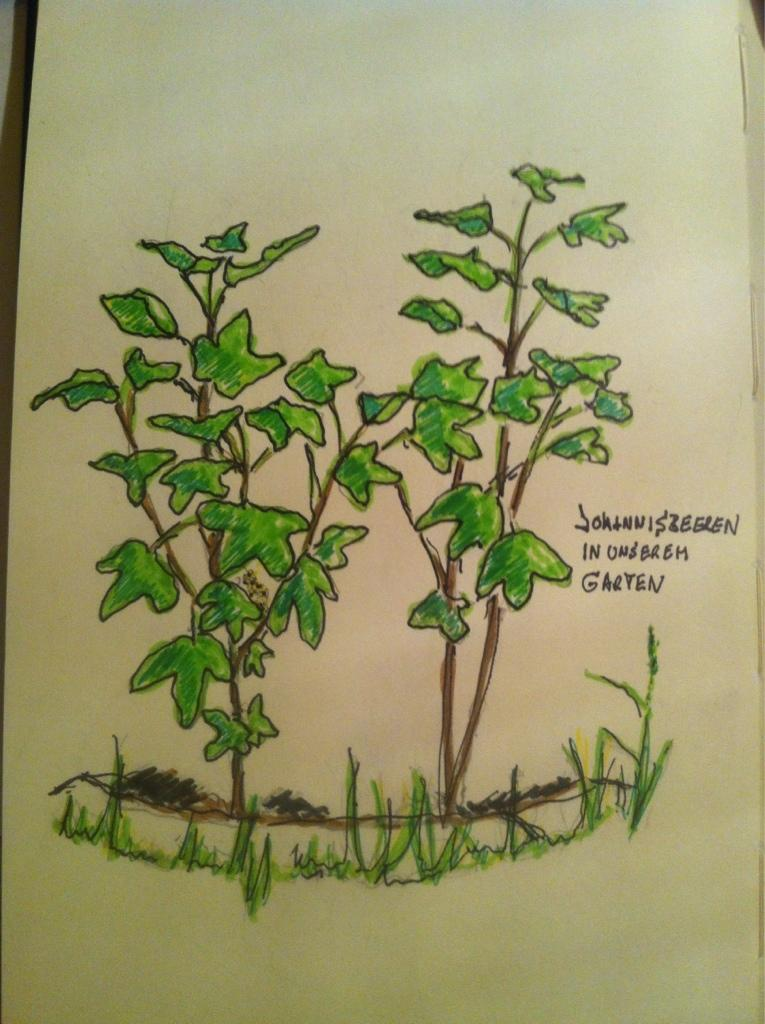What is the main subject of the image? There is a painting in the image. What is depicted in the painting? The painting depicts plants and grass. Are there any words or letters in the painting? Yes, there is text on a paper in the painting. How many ladybugs can be seen on the sweater in the image? There is no sweater or ladybugs present in the image; it features a painting of plants and grass with text on a paper. 